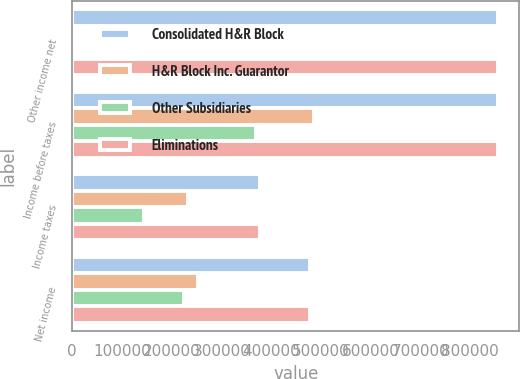Convert chart. <chart><loc_0><loc_0><loc_500><loc_500><stacked_bar_chart><ecel><fcel>Other income net<fcel>Income before taxes<fcel>Income taxes<fcel>Net income<nl><fcel>Consolidated H&R Block<fcel>855564<fcel>855564<fcel>377949<fcel>477615<nl><fcel>H&R Block Inc. Guarantor<fcel>4127<fcel>485993<fcel>232577<fcel>253416<nl><fcel>Other Subsidiaries<fcel>6835<fcel>369591<fcel>145381<fcel>224210<nl><fcel>Eliminations<fcel>855564<fcel>855584<fcel>377958<fcel>477626<nl></chart> 